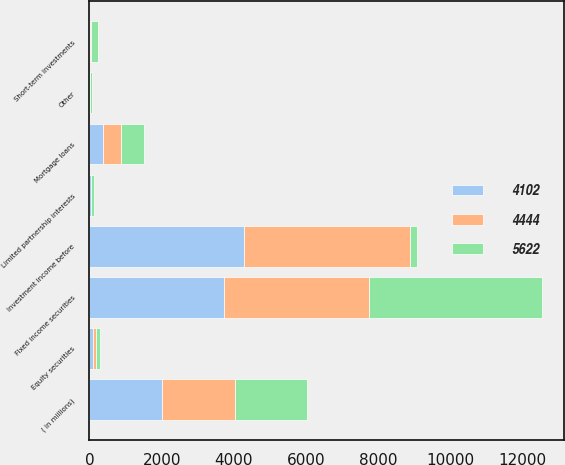<chart> <loc_0><loc_0><loc_500><loc_500><stacked_bar_chart><ecel><fcel>( in millions)<fcel>Fixed income securities<fcel>Equity securities<fcel>Mortgage loans<fcel>Limited partnership interests<fcel>Short-term investments<fcel>Other<fcel>Investment income before<nl><fcel>4102<fcel>2010<fcel>3737<fcel>90<fcel>385<fcel>40<fcel>8<fcel>19<fcel>4279<nl><fcel>4444<fcel>2009<fcel>3998<fcel>80<fcel>498<fcel>17<fcel>27<fcel>10<fcel>4610<nl><fcel>5622<fcel>2008<fcel>4783<fcel>120<fcel>618<fcel>62<fcel>195<fcel>54<fcel>195<nl></chart> 